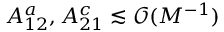<formula> <loc_0><loc_0><loc_500><loc_500>A _ { 1 2 } ^ { a } , A _ { 2 1 } ^ { c } \lesssim \mathcal { O } ( M ^ { - 1 } )</formula> 